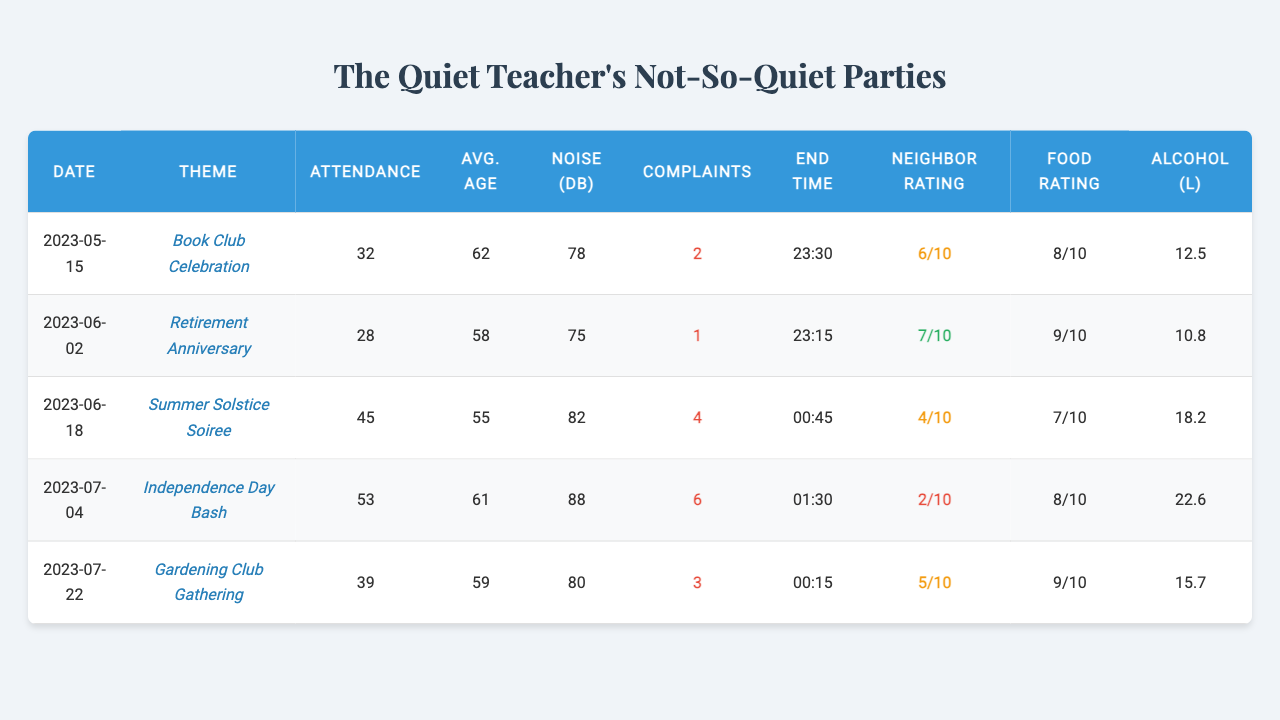What was the theme of the party on July 4th? By looking at the table, I find the entry for the date "2023-07-04" and check the corresponding theme, which is "Independence Day Bash."
Answer: Independence Day Bash How many noise complaints were received at the Summer Solstice Soiree? The Summer Solstice Soiree occurred on "2023-06-18." I locate this date in the table and find that there were 4 noise complaints.
Answer: 4 What was the average age of guests at the Retirement Anniversary party? For the Retirement Anniversary party on "2023-06-02," I check the average guest age, which is given as 58.
Answer: 58 How much alcohol was consumed at the Independence Day Bash? Referring to the table for the date "2023-07-04," I see that the entry states 22.6 liters of alcohol were consumed.
Answer: 22.6 liters What is the total attendance across all parties? I sum the attendance for all the parties: 32 + 28 + 45 + 53 + 39 = 197.
Answer: 197 What is the average noise complaint rating for all parties? I calculate the average of the noise complaints: (2 + 1 + 4 + 6 + 3) / 5 = 16 / 5 = 3.2.
Answer: 3.2 Was there a party where the neighbor satisfaction rating was 10 or more? I check the neighbor satisfaction ratings for all parties and see that none is rated 10 or more; the maximum is 7.
Answer: No Which party had the highest average guest age? I compare the average guest ages: 62, 58, 55, 61, 59. The highest value is 62, which is for the party on "2023-05-15."
Answer: Book Club Celebration How many more noise complaints were there at the Independence Day Bash compared to the Gardening Club Gathering? The Independence Day Bash had 6 complaints and the Gardening Club Gathering had 3. The difference is 6 - 3 = 3 complaints.
Answer: 3 complaints Was the music volume during the Summer Solstice Soiree louder than 80 dB? The music volume recorded for the Summer Solstice Soiree was 82 dB, which is indeed louder than 80 dB.
Answer: Yes 